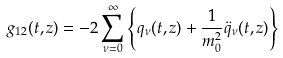Convert formula to latex. <formula><loc_0><loc_0><loc_500><loc_500>g _ { 1 2 } ( t , z ) = - 2 \sum _ { \nu = 0 } ^ { \infty } \left \{ q _ { \nu } ( t , z ) + \frac { 1 } { m _ { 0 } ^ { 2 } } \ddot { q } _ { \nu } ( t , z ) \right \}</formula> 